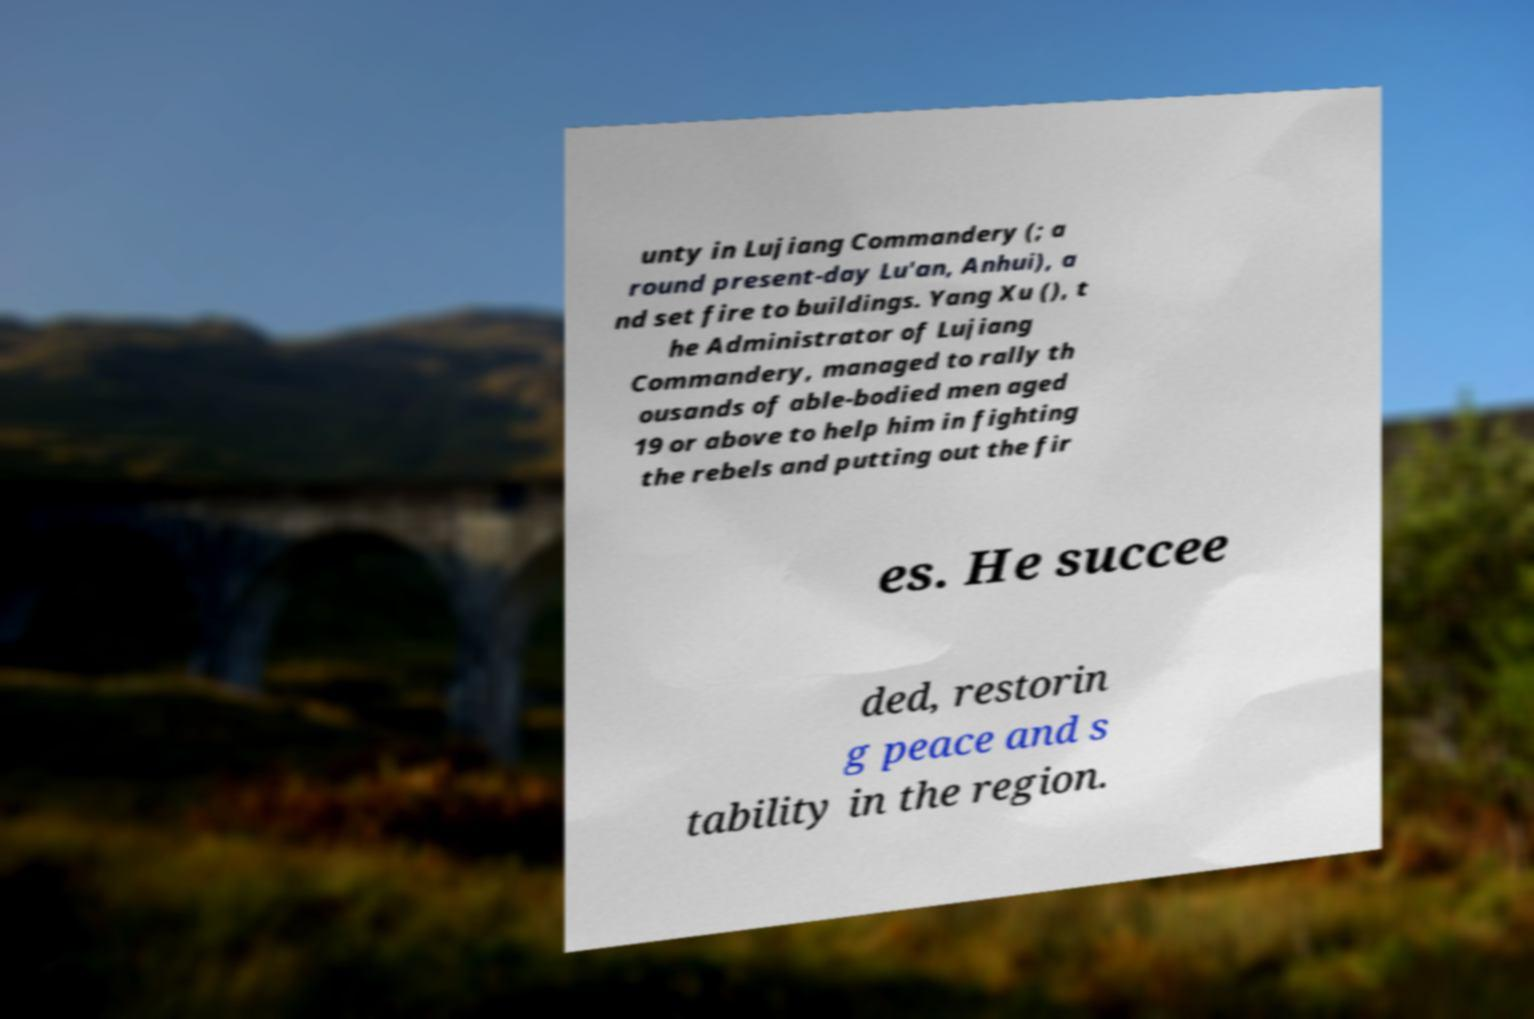What messages or text are displayed in this image? I need them in a readable, typed format. unty in Lujiang Commandery (; a round present-day Lu'an, Anhui), a nd set fire to buildings. Yang Xu (), t he Administrator of Lujiang Commandery, managed to rally th ousands of able-bodied men aged 19 or above to help him in fighting the rebels and putting out the fir es. He succee ded, restorin g peace and s tability in the region. 